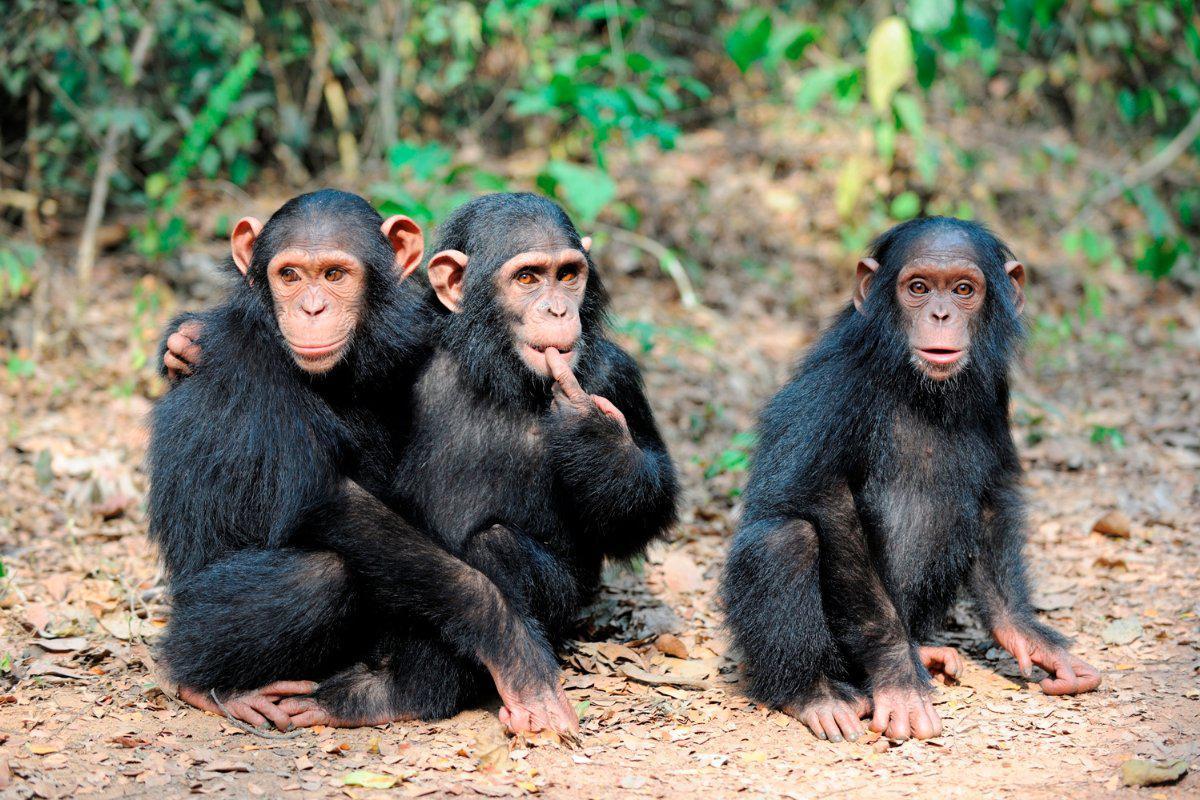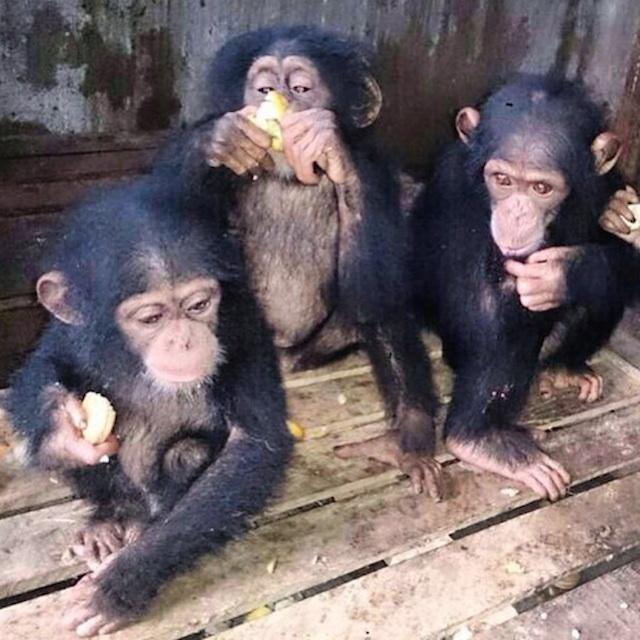The first image is the image on the left, the second image is the image on the right. For the images shown, is this caption "Three juvenile chimps all sit in a row on the ground in the left image." true? Answer yes or no. Yes. 